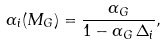<formula> <loc_0><loc_0><loc_500><loc_500>\alpha _ { i } ( M _ { G } ) = \frac { \alpha _ { G } } { 1 - \alpha _ { G } \, \Delta _ { i } } ,</formula> 